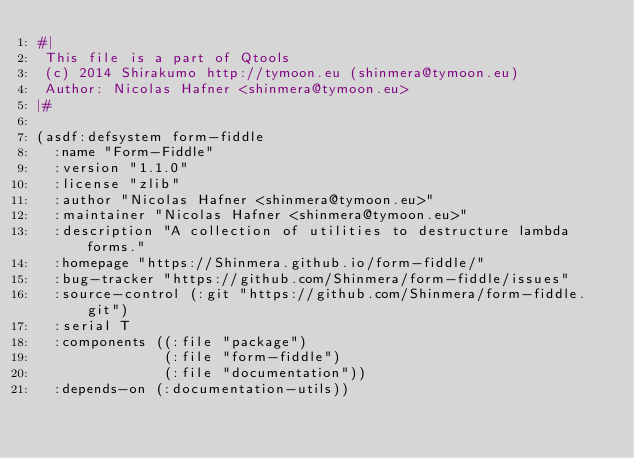<code> <loc_0><loc_0><loc_500><loc_500><_Lisp_>#|
 This file is a part of Qtools
 (c) 2014 Shirakumo http://tymoon.eu (shinmera@tymoon.eu)
 Author: Nicolas Hafner <shinmera@tymoon.eu>
|#

(asdf:defsystem form-fiddle
  :name "Form-Fiddle"
  :version "1.1.0"
  :license "zlib"
  :author "Nicolas Hafner <shinmera@tymoon.eu>"
  :maintainer "Nicolas Hafner <shinmera@tymoon.eu>"
  :description "A collection of utilities to destructure lambda forms."
  :homepage "https://Shinmera.github.io/form-fiddle/"
  :bug-tracker "https://github.com/Shinmera/form-fiddle/issues"
  :source-control (:git "https://github.com/Shinmera/form-fiddle.git")
  :serial T
  :components ((:file "package")
               (:file "form-fiddle")
               (:file "documentation"))
  :depends-on (:documentation-utils))
</code> 